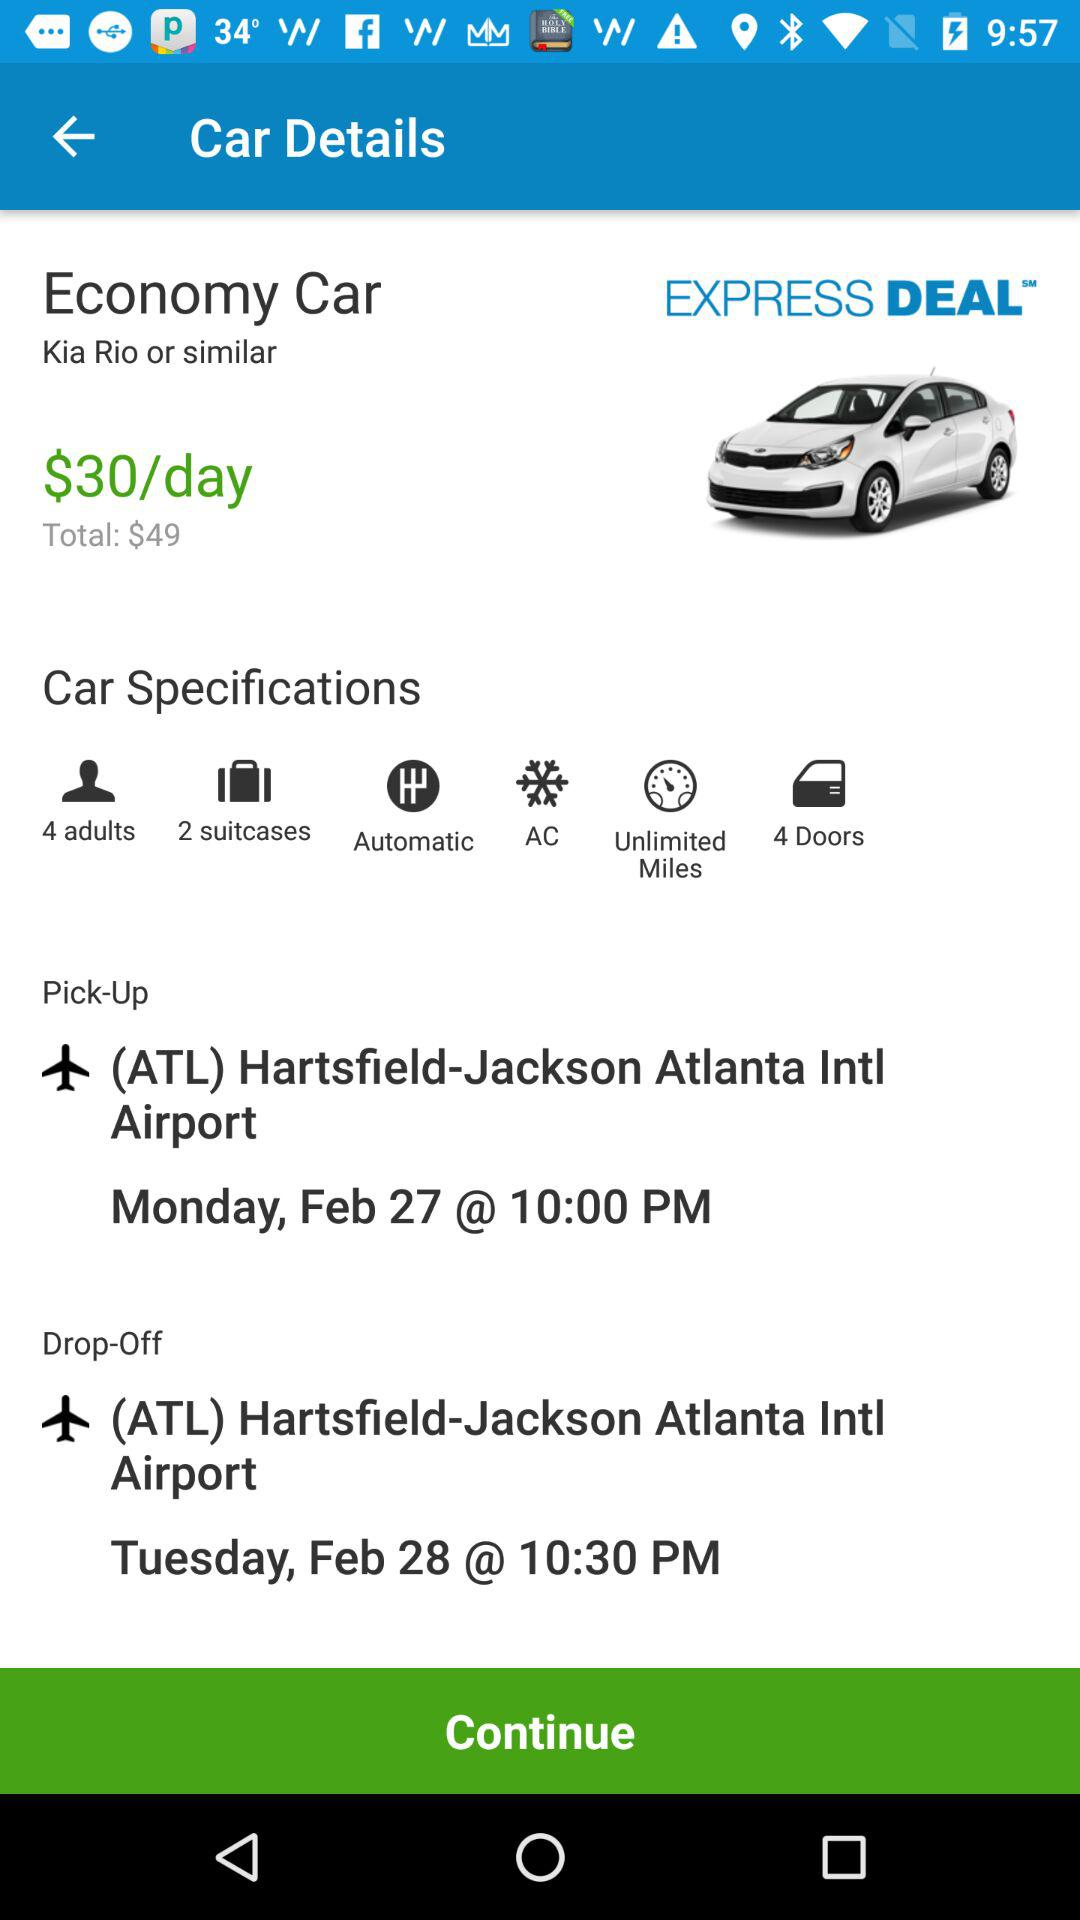What is the total price of an economy car? The total price is $49. 